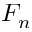Convert formula to latex. <formula><loc_0><loc_0><loc_500><loc_500>F _ { n }</formula> 